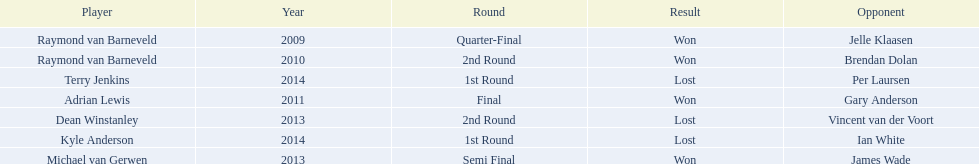Who were all the players? Raymond van Barneveld, Raymond van Barneveld, Adrian Lewis, Dean Winstanley, Michael van Gerwen, Terry Jenkins, Kyle Anderson. Which of these played in 2014? Terry Jenkins, Kyle Anderson. Who were their opponents? Per Laursen, Ian White. Which of these beat terry jenkins? Per Laursen. 